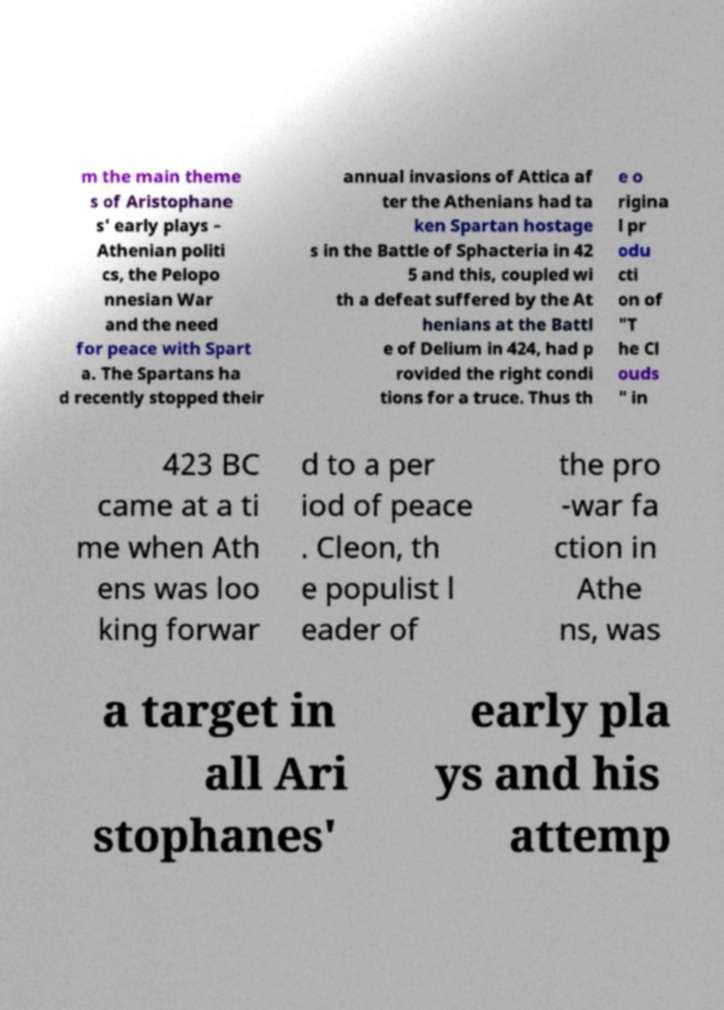I need the written content from this picture converted into text. Can you do that? m the main theme s of Aristophane s' early plays – Athenian politi cs, the Pelopo nnesian War and the need for peace with Spart a. The Spartans ha d recently stopped their annual invasions of Attica af ter the Athenians had ta ken Spartan hostage s in the Battle of Sphacteria in 42 5 and this, coupled wi th a defeat suffered by the At henians at the Battl e of Delium in 424, had p rovided the right condi tions for a truce. Thus th e o rigina l pr odu cti on of "T he Cl ouds " in 423 BC came at a ti me when Ath ens was loo king forwar d to a per iod of peace . Cleon, th e populist l eader of the pro -war fa ction in Athe ns, was a target in all Ari stophanes' early pla ys and his attemp 